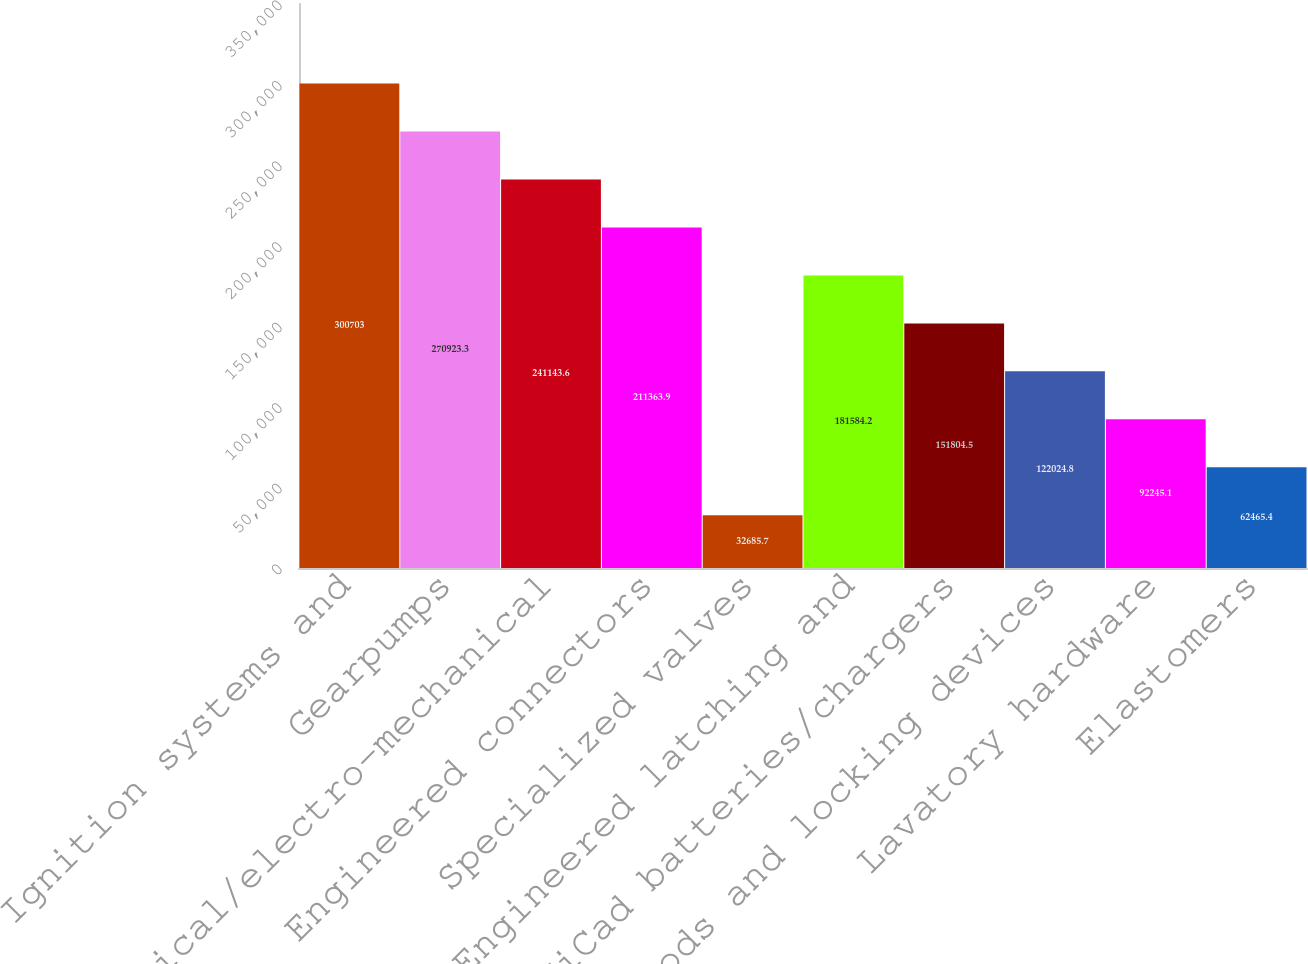<chart> <loc_0><loc_0><loc_500><loc_500><bar_chart><fcel>Ignition systems and<fcel>Gearpumps<fcel>Mechanical/electro-mechanical<fcel>Engineered connectors<fcel>Specialized valves<fcel>Engineered latching and<fcel>NiCad batteries/chargers<fcel>Rods and locking devices<fcel>Lavatory hardware<fcel>Elastomers<nl><fcel>300703<fcel>270923<fcel>241144<fcel>211364<fcel>32685.7<fcel>181584<fcel>151804<fcel>122025<fcel>92245.1<fcel>62465.4<nl></chart> 